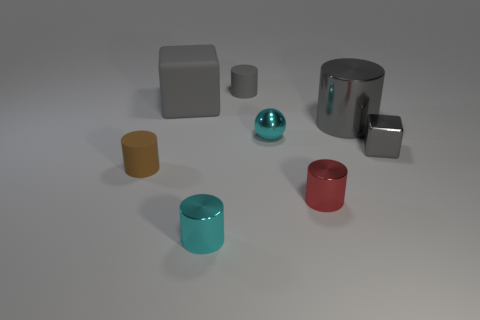Subtract all green balls. How many gray cylinders are left? 2 Add 1 matte things. How many objects exist? 9 Subtract all gray matte cylinders. How many cylinders are left? 4 Subtract all red cylinders. How many cylinders are left? 4 Subtract all cylinders. How many objects are left? 3 Subtract all yellow cylinders. Subtract all blue blocks. How many cylinders are left? 5 Add 5 rubber cylinders. How many rubber cylinders are left? 7 Add 1 brown rubber objects. How many brown rubber objects exist? 2 Subtract 0 gray balls. How many objects are left? 8 Subtract all big matte blocks. Subtract all tiny gray matte cylinders. How many objects are left? 6 